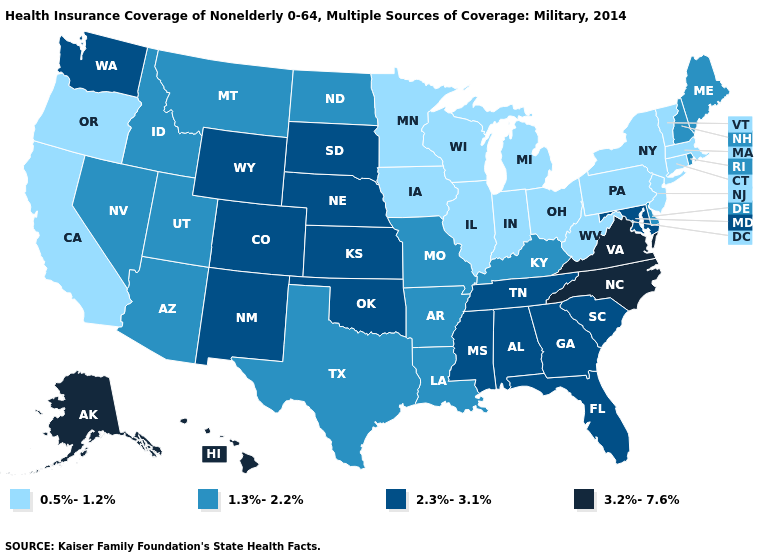Does Nebraska have a higher value than Oklahoma?
Short answer required. No. Does West Virginia have the lowest value in the South?
Write a very short answer. Yes. Name the states that have a value in the range 1.3%-2.2%?
Give a very brief answer. Arizona, Arkansas, Delaware, Idaho, Kentucky, Louisiana, Maine, Missouri, Montana, Nevada, New Hampshire, North Dakota, Rhode Island, Texas, Utah. Does Idaho have a lower value than Washington?
Give a very brief answer. Yes. Does Minnesota have the lowest value in the MidWest?
Concise answer only. Yes. What is the value of Colorado?
Quick response, please. 2.3%-3.1%. What is the lowest value in the South?
Give a very brief answer. 0.5%-1.2%. What is the value of Wyoming?
Concise answer only. 2.3%-3.1%. Does Illinois have the lowest value in the USA?
Quick response, please. Yes. What is the value of Washington?
Short answer required. 2.3%-3.1%. What is the value of North Carolina?
Quick response, please. 3.2%-7.6%. Does Missouri have the lowest value in the MidWest?
Quick response, please. No. Does the first symbol in the legend represent the smallest category?
Give a very brief answer. Yes. Name the states that have a value in the range 0.5%-1.2%?
Be succinct. California, Connecticut, Illinois, Indiana, Iowa, Massachusetts, Michigan, Minnesota, New Jersey, New York, Ohio, Oregon, Pennsylvania, Vermont, West Virginia, Wisconsin. 